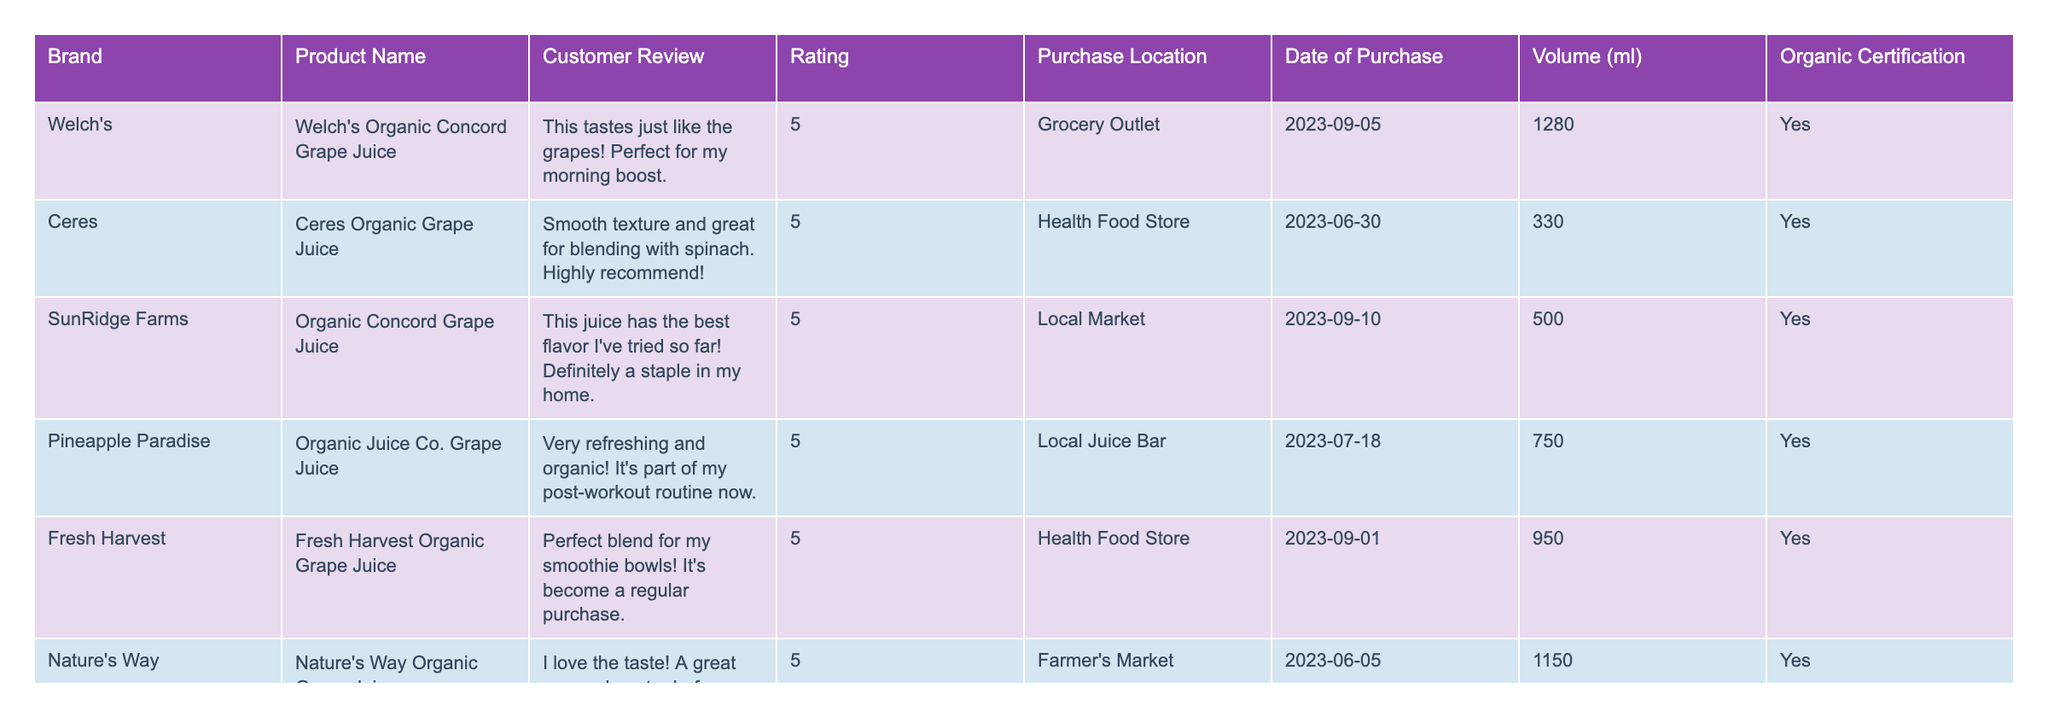What is the highest rating given to an organic grape juice? The table shows ratings of different organic grape juice brands. By reviewing the ratings, it's clear that the highest rating listed is 5.
Answer: 5 Which brand received a rating of 3? Looking through the table, only Belvoir Farm has a rating of 3 while all other brands have higher ratings.
Answer: Belvoir Farm How many different locations were used to purchase the organic grape juice? By examining the "Purchase Location" column, we can count the unique locations: Grocery Outlet, Health Food Store, Local Market, Local Juice Bar, Farmer's Market, Amazon, and Whole Foods. This totals to 7 locations.
Answer: 7 Which brand had the only customer review that mentioned price? The review from Belvoir Farm noted that the taste was good but mentioned the price as being high for the quantity.
Answer: Belvoir Farm What is the average rating of all the organic grape juices listed? To find the average, we add all the ratings together (5 + 5 + 5 + 5 + 5 + 5 + 3 + 5) = 38 and then divide by the number of reviews, which is 8. So, 38 / 8 = 4.75.
Answer: 4.75 Which product was purchased at a grocery outlet and what was its rating? The table indicates that Welch's Organic Concord Grape Juice was purchased at Grocery Outlet and received a rating of 5.
Answer: Welch's Organic Concord Grape Juice, 5 How many organic grape juices were rated 5? By reviewing the ratings in the table, we find that six juices received a rating of 5: Welch's, Ceres, SunRidge Farms, Pineapple Paradise, Fresh Harvest, and Grandpa's Garden, making a total of 6.
Answer: 6 What can be inferred about the organic certification of the products listed? Checking the "Organic Certification" column, all products listed have "Yes" under this certification, indicating all are certified organic.
Answer: All products are organic certified Did any of the reviews mention smoothies specifically? The customer reviews from Ceres and Fresh Harvest both mentioned smoothies directly in relation to their products.
Answer: Yes Which product has the largest volume in milliliters? Comparing the "Volume (ml)" column, Welch's Organic Concord Grape Juice has the largest volume at 1280 ml.
Answer: Welch's Organic Concord Grape Juice, 1280 ml 